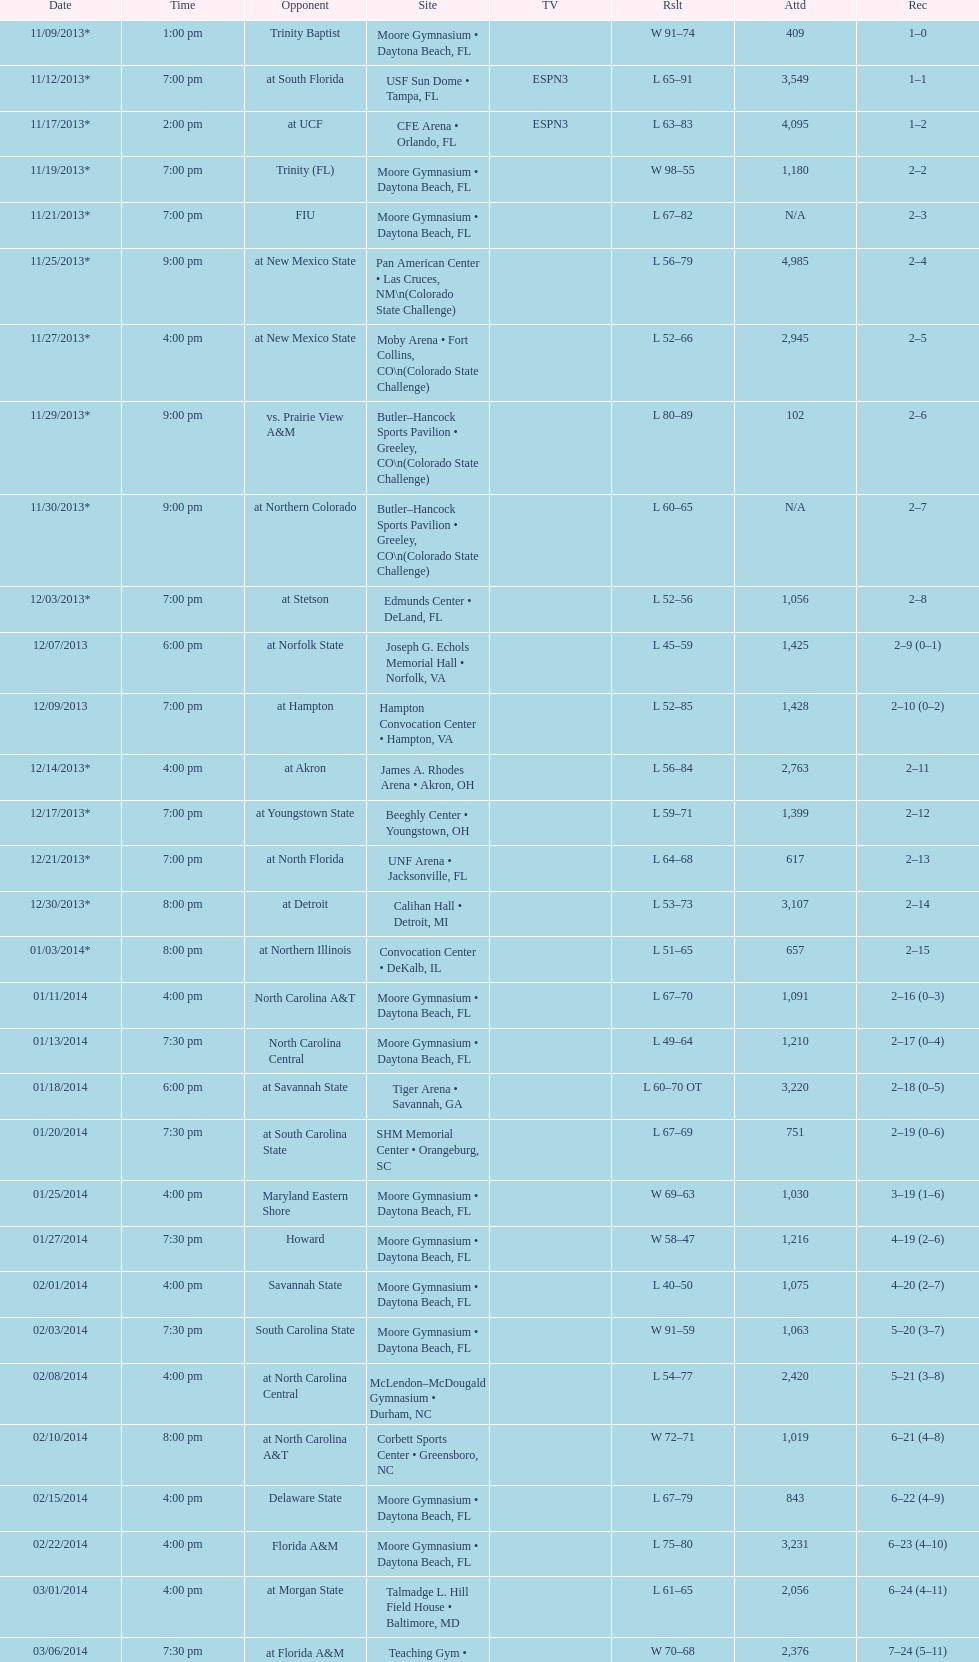What is the total attendance on 11/09/2013? 409. 